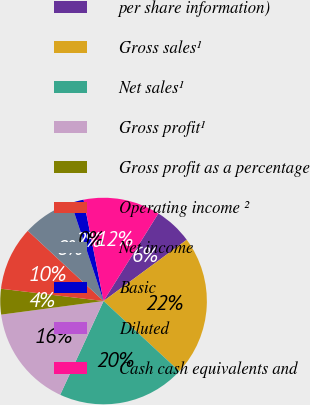Convert chart to OTSL. <chart><loc_0><loc_0><loc_500><loc_500><pie_chart><fcel>per share information)<fcel>Gross sales¹<fcel>Net sales¹<fcel>Gross profit¹<fcel>Gross profit as a percentage<fcel>Operating income ²<fcel>Net income<fcel>Basic<fcel>Diluted<fcel>Cash cash equivalents and<nl><fcel>6.0%<fcel>22.0%<fcel>20.0%<fcel>16.0%<fcel>4.0%<fcel>10.0%<fcel>8.0%<fcel>2.0%<fcel>0.0%<fcel>12.0%<nl></chart> 